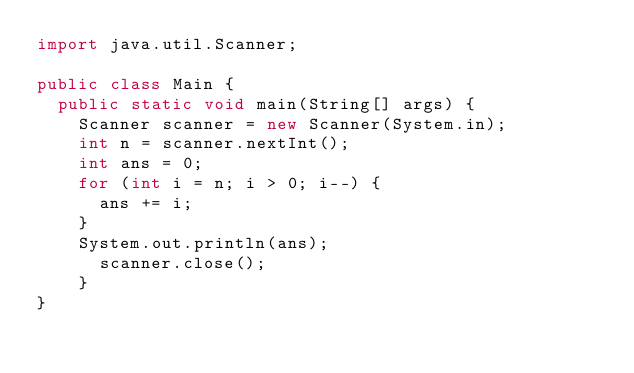<code> <loc_0><loc_0><loc_500><loc_500><_Java_>import java.util.Scanner;

public class Main {
	public static void main(String[] args) {
		Scanner scanner = new Scanner(System.in);
		int n = scanner.nextInt();
		int ans = 0;
		for (int i = n; i > 0; i--) {
			ans += i;
		}
		System.out.println(ans);
	    scanner.close();
		}
}
</code> 